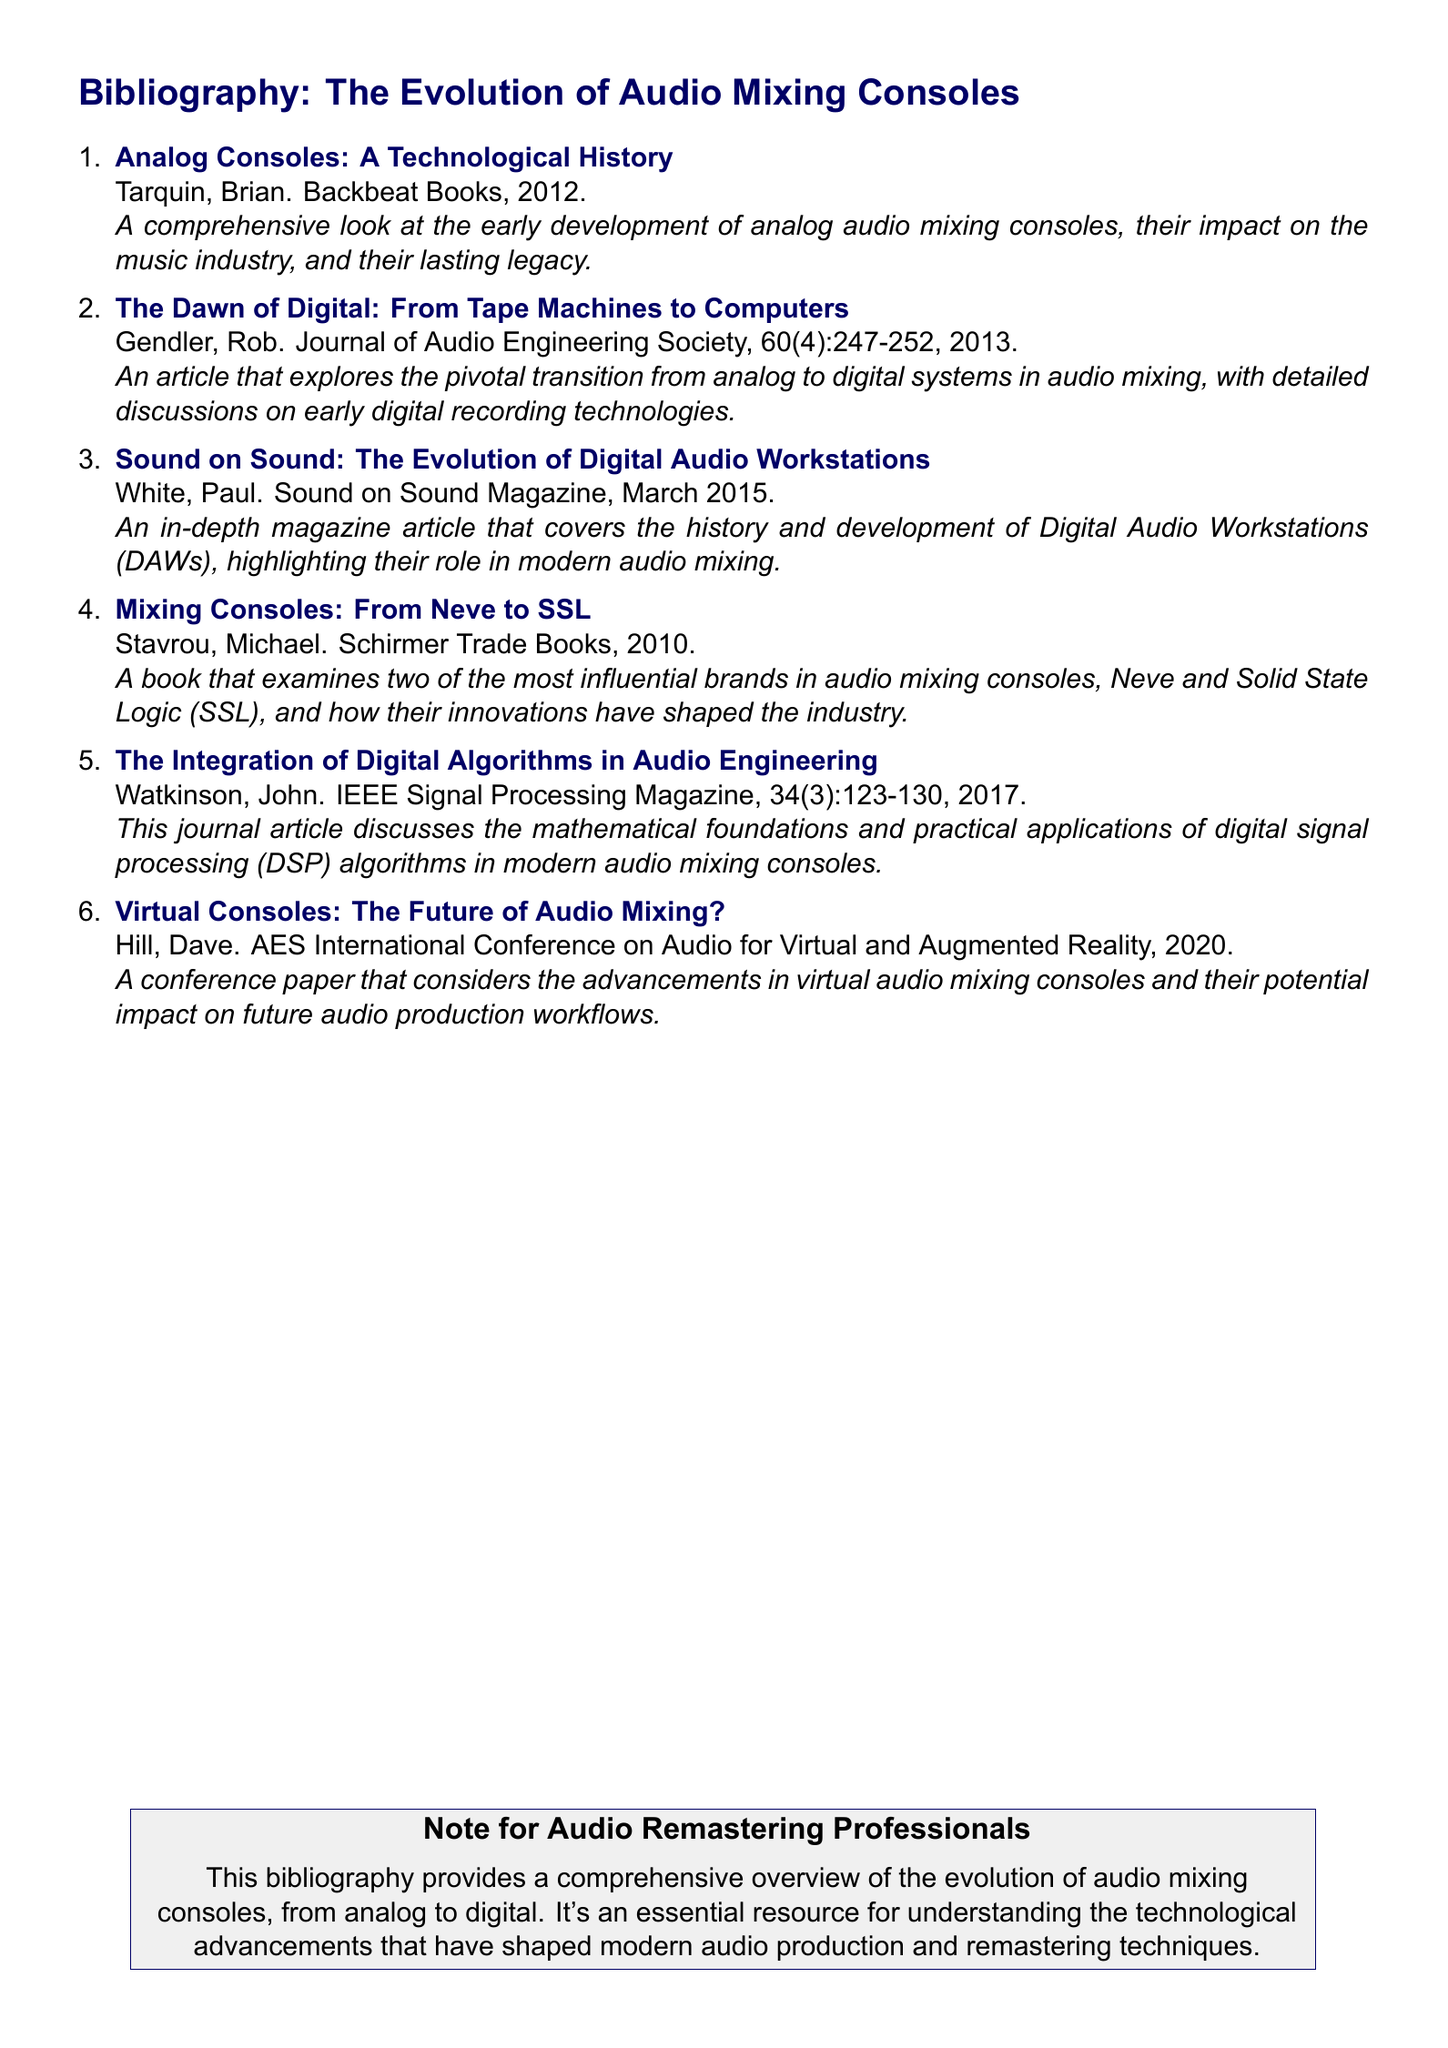What is the title of the first entry? The title of the first entry outlines the focus of the source listed, which is about the technological aspects of analog consoles.
Answer: Analog Consoles: A Technological History Who is the author of the second entry? The author of the second entry is credited for their contribution to understanding the transition from analog to digital audio systems.
Answer: Rob Gendler In what year was "Mixing Consoles: From Neve to SSL" published? The publication date indicates when the book was released, relevant for understanding its context in the timeline of audio console evolution.
Answer: 2010 What type of publication is "The Integration of Digital Algorithms in Audio Engineering"? This identifies the nature of the source and its format, providing insight into its academic relevance in the field of audio engineering.
Answer: Journal article What is the focus of Hill's conference paper? The focus summarizes the primary theme of the conference paper, particularly looking towards future advancements in audio mixing technology.
Answer: Advancements in virtual audio mixing consoles How many sources discuss digital audio systems? This figure helps understand the ratio of entries that cover the digital transition compared to analog topics in the bibliography.
Answer: Three What does the note at the end highlight for audio remastering professionals? The note emphasizes the significance of the bibliography, which is pertinent for the target audience in audio remastering.
Answer: Overview of the evolution of audio mixing consoles What is the publication month of the article by Paul White? This detail gives insight into the timing of the article’s release which may align with technological advancements in the industry.
Answer: March Which two brands are highlighted in relation to innovations in mixing consoles? This identifies critical players in the industry that have made significant innovations in audio mixing technology.
Answer: Neve and SSL 